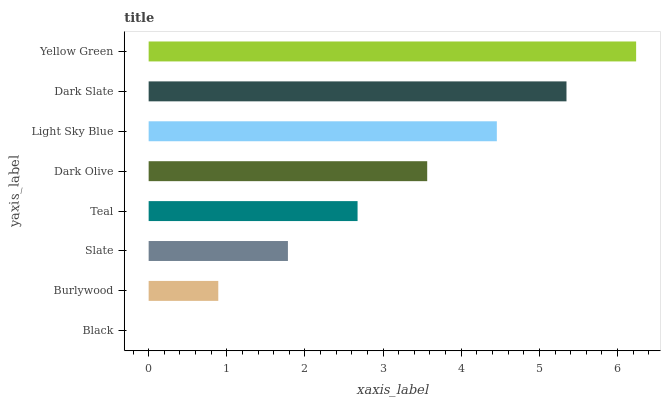Is Black the minimum?
Answer yes or no. Yes. Is Yellow Green the maximum?
Answer yes or no. Yes. Is Burlywood the minimum?
Answer yes or no. No. Is Burlywood the maximum?
Answer yes or no. No. Is Burlywood greater than Black?
Answer yes or no. Yes. Is Black less than Burlywood?
Answer yes or no. Yes. Is Black greater than Burlywood?
Answer yes or no. No. Is Burlywood less than Black?
Answer yes or no. No. Is Dark Olive the high median?
Answer yes or no. Yes. Is Teal the low median?
Answer yes or no. Yes. Is Dark Slate the high median?
Answer yes or no. No. Is Slate the low median?
Answer yes or no. No. 